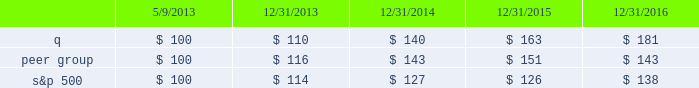Stock performance graph this performance graph shall not be deemed 201cfiled 201d for purposes of section 18 of the exchange act , or incorporated by reference into any filing of quintiles ims holdings , inc .
Under the exchange act or under the securities act , except as shall be expressly set forth by specific reference in such filing .
The following graph shows a comparison from may 9 , 2013 ( the date our common stock commenced trading on the nyse ) through december 31 , 2016 of the cumulative total return for our common stock , the standard & poor 2019s 500 stock index ( 201cs&p 500 201d ) and a select peer group .
The peer group consists of cerner corporation , charles river laboratories , inc. , dun & bradstreet corporation , equifax inc. , icon plc , ihs markit ltd. , inc research holdings , laboratory corporation of america holdings , nielsen n.v. , parexel international corporation , inc. , pra health sciences , inc. , thomson reuters corporation and verisk analytics , inc .
The companies in our peer group are publicly traded information services , information technology or contract research companies , and thus share similar business model characteristics to quintilesims , or provide services to similar customers as quintilesims .
Many of these companies are also used by our compensation committee for purposes of compensation benchmarking .
The graph assumes that $ 100 was invested in quintilesims , the s&p 500 and the peer group as of the close of market on may 9 , 2013 , assumes the reinvestments of dividends , if any .
The s&p 500 and our peer group are included for comparative purposes only .
They do not necessarily reflect management 2019s opinion that the s&p 500 and our peer group are an appropriate measure of the relative performance of the stock involved , and they are not intended to forecast or be indicative of possible future performance of our common stock .
S&p 500 quintilesims peer group .
Item 6 .
Selected financial data we have derived the following consolidated statements of income data for 2016 , 2015 and 2014 and consolidated balance sheet data as of december 31 , 2016 and 2015 from our audited consolidated financial .
What is the return on investment for q if the investment is sold at the end of year 2014? 
Computations: ((140 - 100) / 100)
Answer: 0.4. 